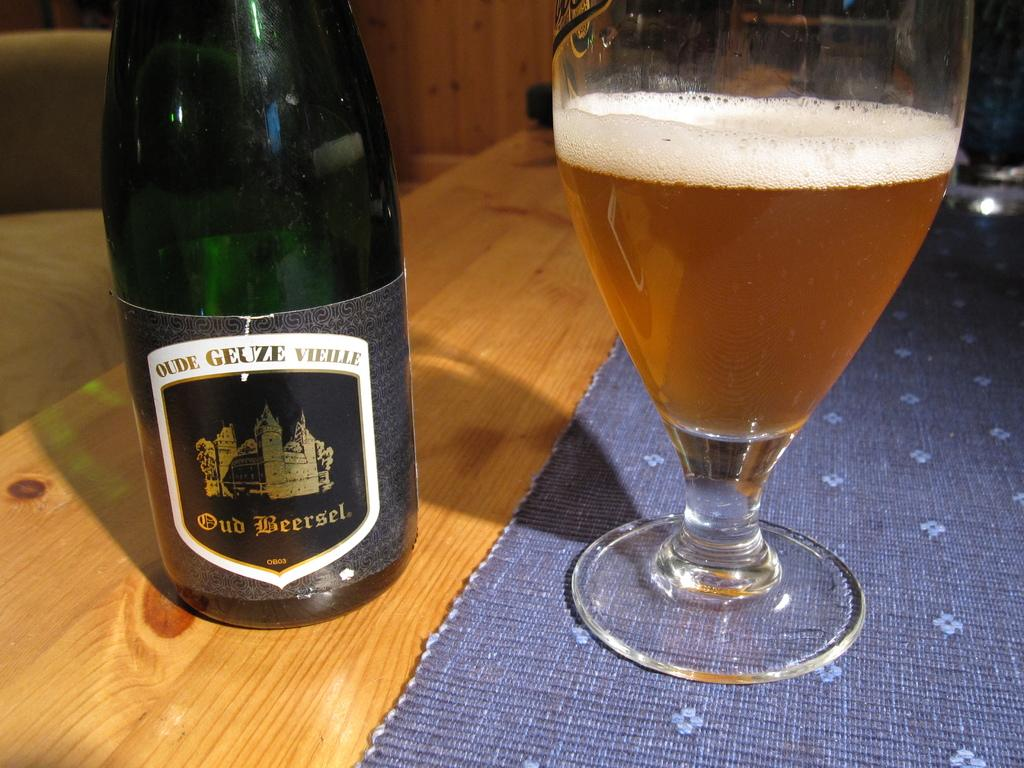What type of table is in the image? There is a wooden table in the image. What is placed on the wooden table? There is a wine bottle and a glass on the table. Is there any covering or decoration on the table? Yes, there is a cloth on the table. What shape is the oatmeal on the table in the image? There is no oatmeal present in the image. 